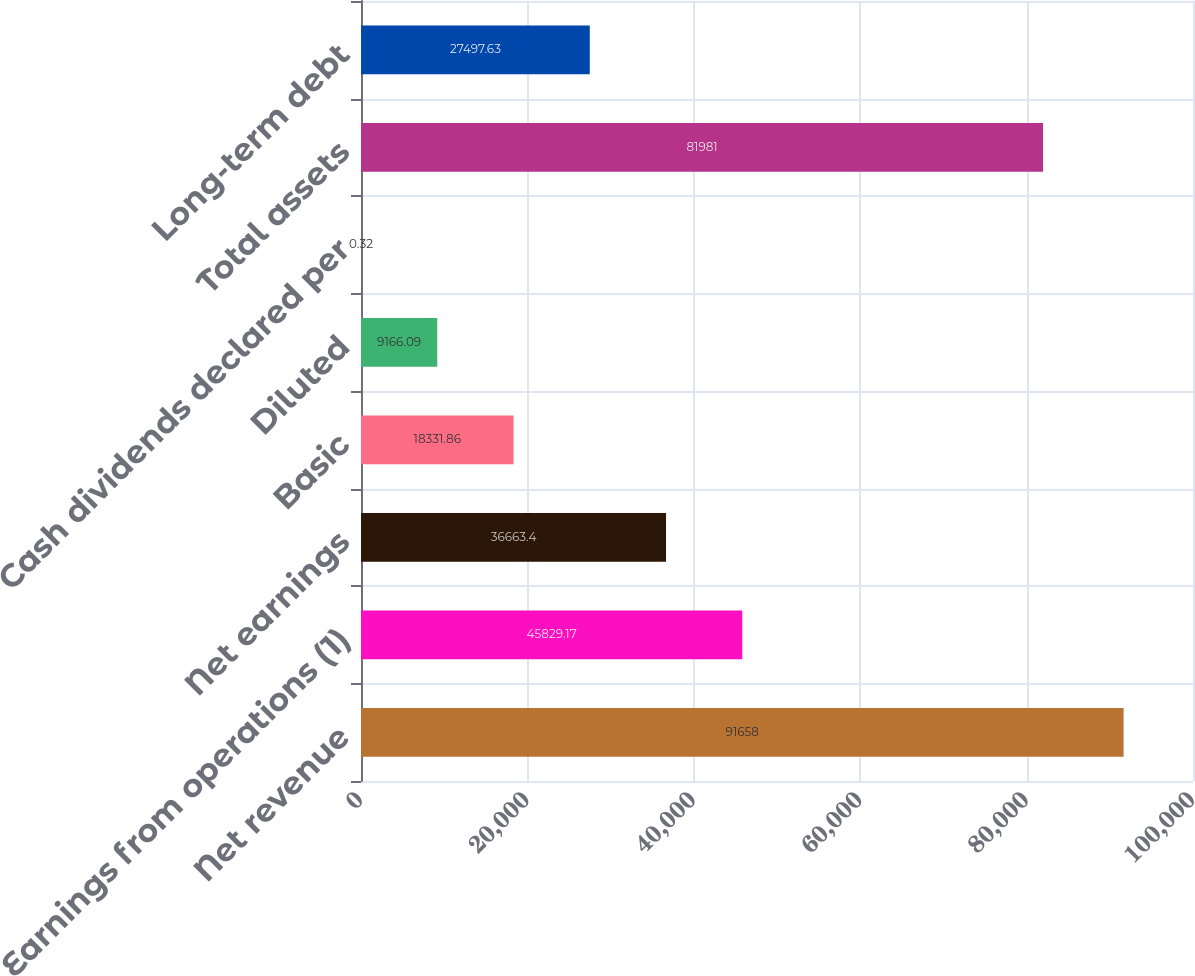Convert chart. <chart><loc_0><loc_0><loc_500><loc_500><bar_chart><fcel>Net revenue<fcel>Earnings from operations (1)<fcel>Net earnings<fcel>Basic<fcel>Diluted<fcel>Cash dividends declared per<fcel>Total assets<fcel>Long-term debt<nl><fcel>91658<fcel>45829.2<fcel>36663.4<fcel>18331.9<fcel>9166.09<fcel>0.32<fcel>81981<fcel>27497.6<nl></chart> 